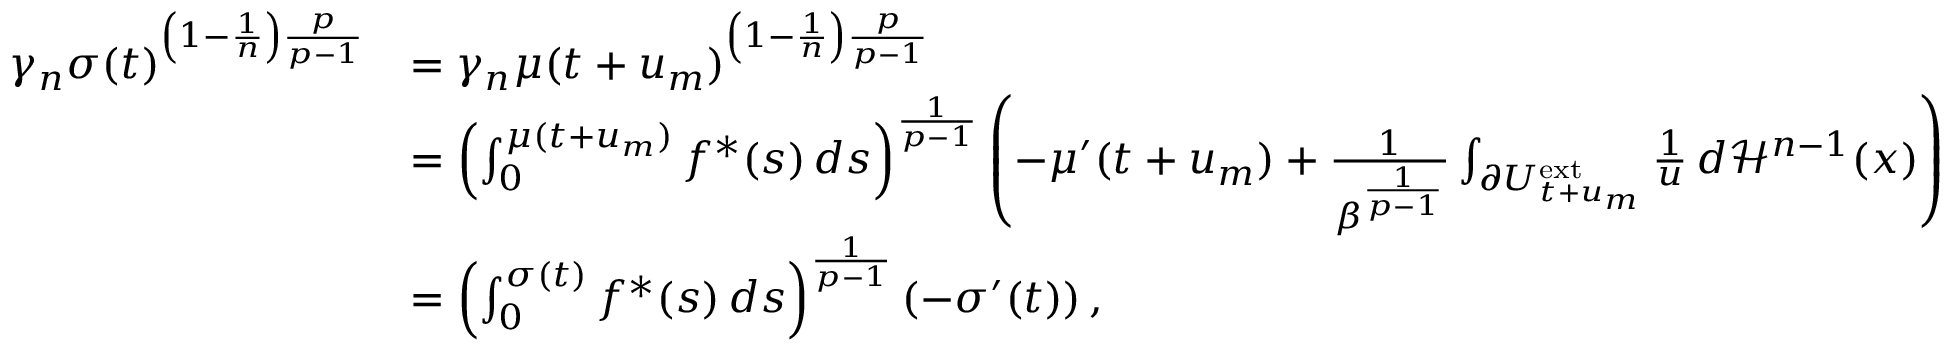<formula> <loc_0><loc_0><loc_500><loc_500>\begin{array} { r l } { \gamma _ { n } \sigma ( t ) ^ { \left ( 1 - \frac { 1 } { n } \right ) \frac { p } { p - 1 } } } & { = \gamma _ { n } \mu ( t + u _ { m } ) ^ { \left ( 1 - \frac { 1 } { n } \right ) \frac { p } { p - 1 } } } \\ & { = \left ( \int _ { 0 } ^ { \mu ( t + u _ { m } ) } f ^ { \ast } ( s ) \, d s \right ) ^ { \frac { 1 } { p - 1 } } \left ( - \mu ^ { \prime } ( t + u _ { m } ) + \frac { 1 } { \beta ^ { \frac { 1 } { p - 1 } } } \int _ { \partial U _ { t + u _ { m } } ^ { e x t } } \frac { 1 } { u } \, d \mathcal { H } ^ { n - 1 } ( x ) \right ) } \\ & { = \left ( \int _ { 0 } ^ { \sigma ( t ) } f ^ { \ast } ( s ) \, d s \right ) ^ { \frac { 1 } { p - 1 } } \left ( - \sigma ^ { \prime } ( t ) \right ) , } \end{array}</formula> 